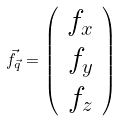<formula> <loc_0><loc_0><loc_500><loc_500>\vec { f } _ { \vec { q } } = \left ( \begin{array} { r } f _ { x } \\ f _ { y } \\ f _ { z } \end{array} \right )</formula> 